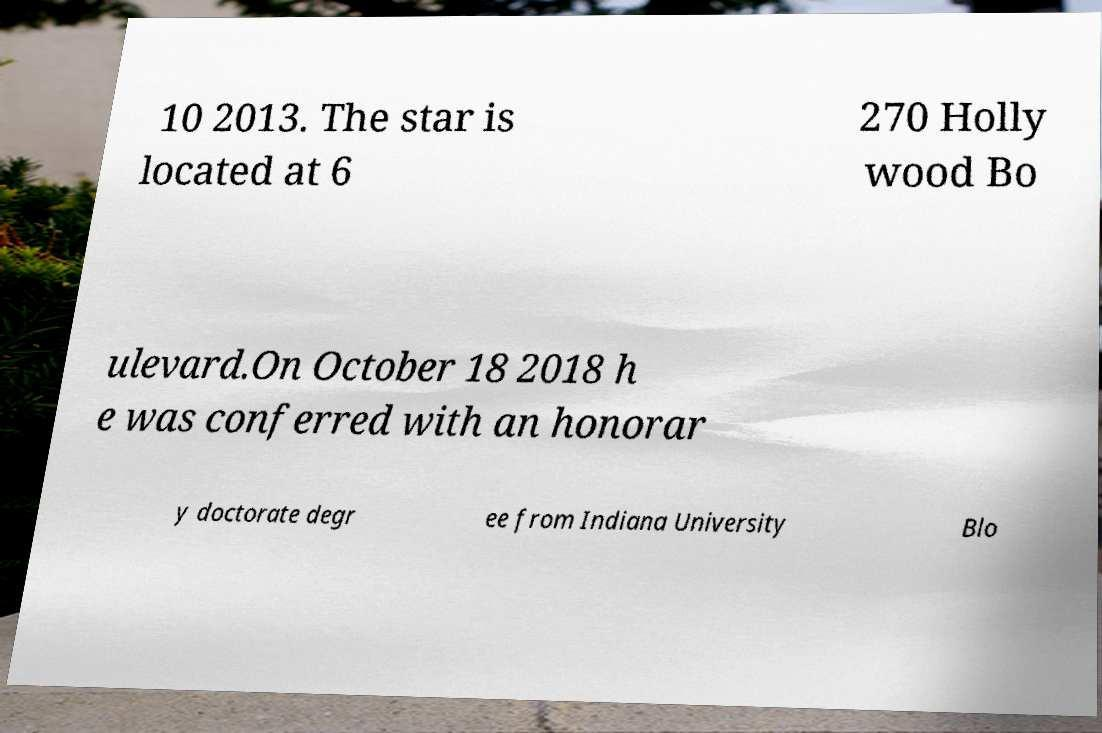Could you extract and type out the text from this image? 10 2013. The star is located at 6 270 Holly wood Bo ulevard.On October 18 2018 h e was conferred with an honorar y doctorate degr ee from Indiana University Blo 